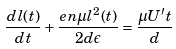Convert formula to latex. <formula><loc_0><loc_0><loc_500><loc_500>\frac { d l ( t ) } { d t } + \frac { e n \mu l ^ { 2 } ( t ) } { 2 d \epsilon } = \frac { \mu U ^ { \prime } t } { d }</formula> 